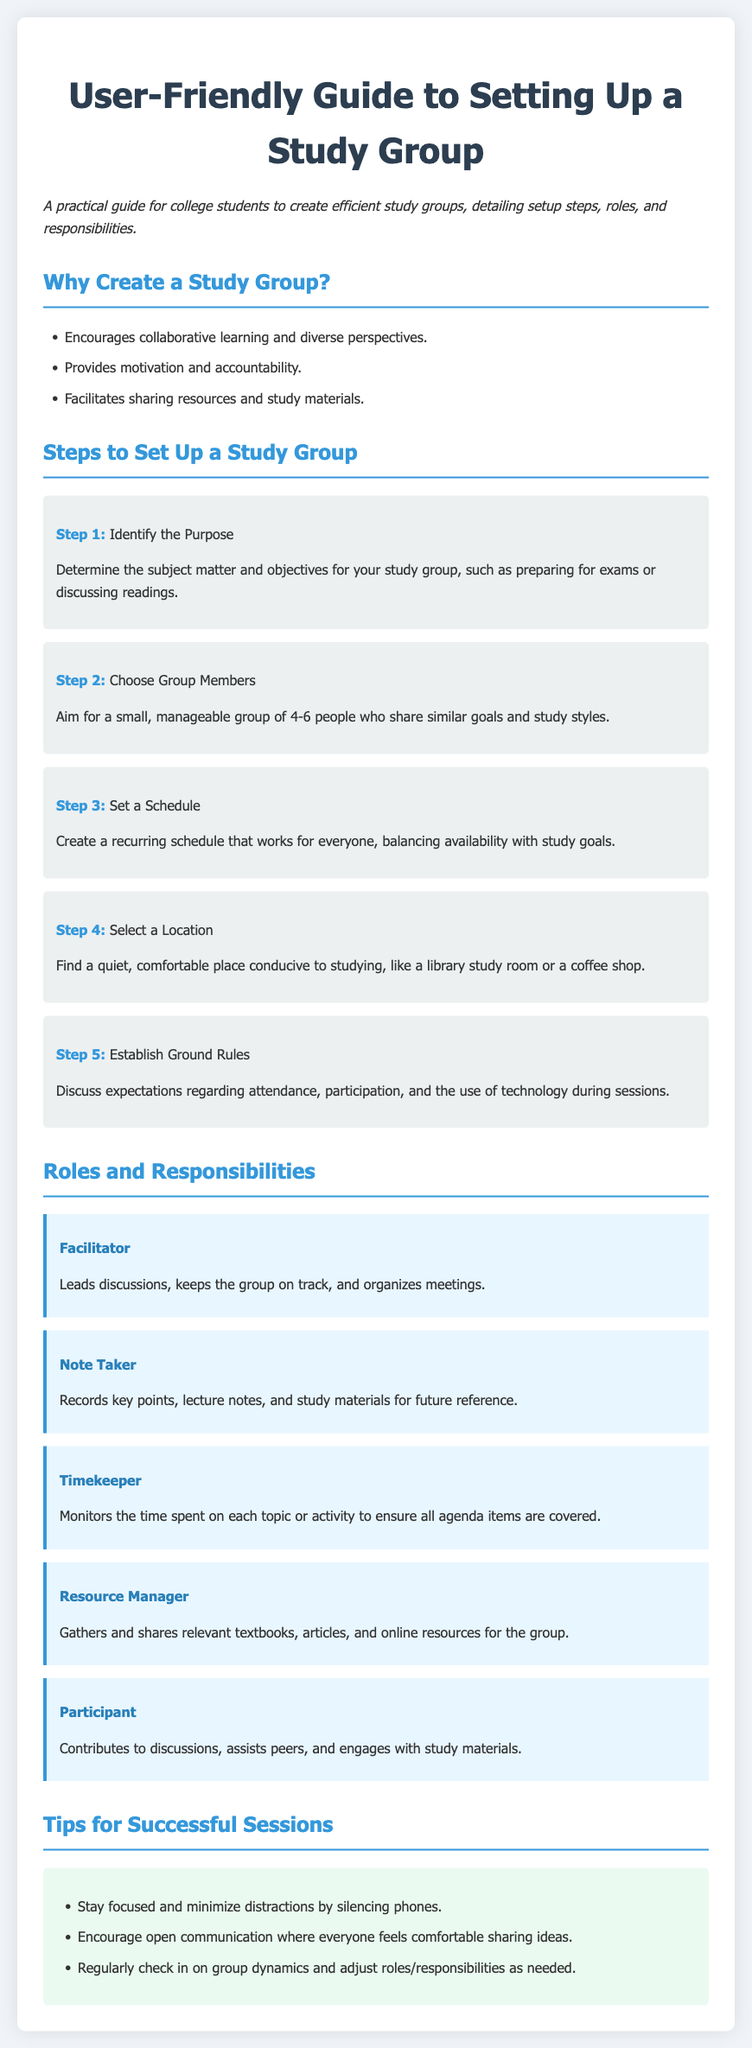What is the title of the document? The title is stated at the top of the document as "User-Friendly Guide to Setting Up a Study Group."
Answer: User-Friendly Guide to Setting Up a Study Group How many steps are there to set up a study group? The document outlines a total of five steps for setting up a study group.
Answer: 5 Who is responsible for gathering and sharing relevant resources? This responsibility is outlined in the roles and responsibilities section, specifically for the Resource Manager role.
Answer: Resource Manager What role leads discussions and keeps the group on track? The document specifies the Facilitator as the role responsible for leading discussions and keeping the group on track.
Answer: Facilitator What is one of the tips for successful sessions? The tips section includes various suggestions, one of which is to "Stay focused and minimize distractions by silencing phones."
Answer: Stay focused and minimize distractions by silencing phones What is the purpose of identifying the purpose of the study group? It is to determine the subject matter and objectives for the study group, such as preparing for exams or discussing readings.
Answer: Determine the subject matter and objectives How many group members are suggested for a manageable study group? According to the document, it suggests having around four to six members for a manageable study group.
Answer: 4-6 What should participants do in the study group? Participants are expected to contribute to discussions, assist peers, and engage with study materials.
Answer: Contribute to discussions, assist peers, and engage with study materials Where should the study group ideally meet? The document advises finding a quiet and comfortable place conducive to studying, like a library study room or a coffee shop.
Answer: Library study room or a coffee shop 